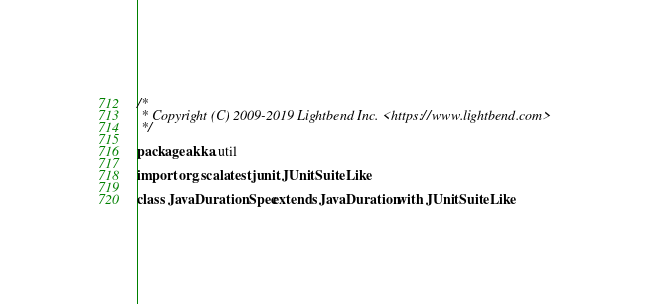<code> <loc_0><loc_0><loc_500><loc_500><_Scala_>/*
 * Copyright (C) 2009-2019 Lightbend Inc. <https://www.lightbend.com>
 */

package akka.util

import org.scalatest.junit.JUnitSuiteLike

class JavaDurationSpec extends JavaDuration with JUnitSuiteLike
</code> 